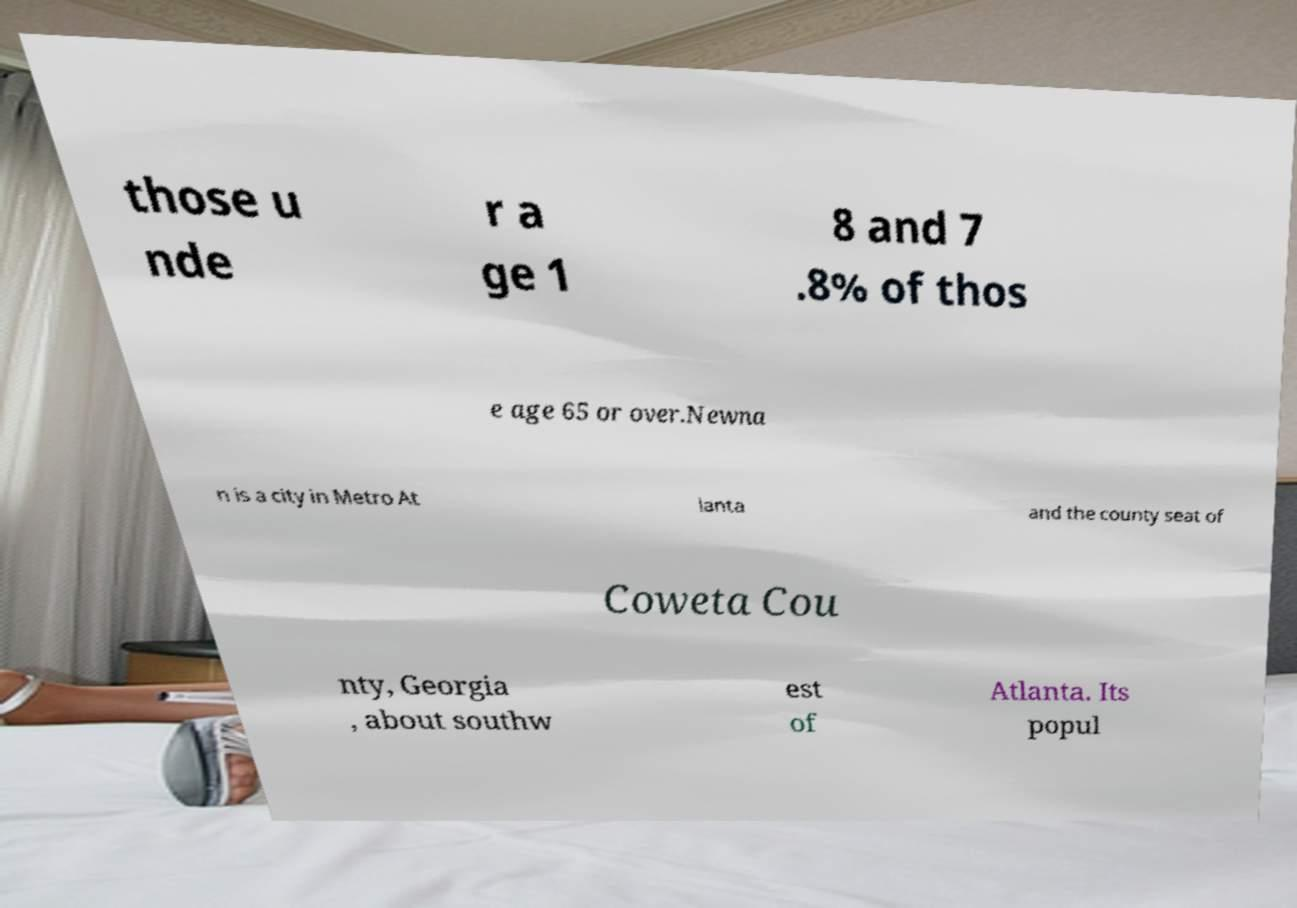Could you assist in decoding the text presented in this image and type it out clearly? those u nde r a ge 1 8 and 7 .8% of thos e age 65 or over.Newna n is a city in Metro At lanta and the county seat of Coweta Cou nty, Georgia , about southw est of Atlanta. Its popul 